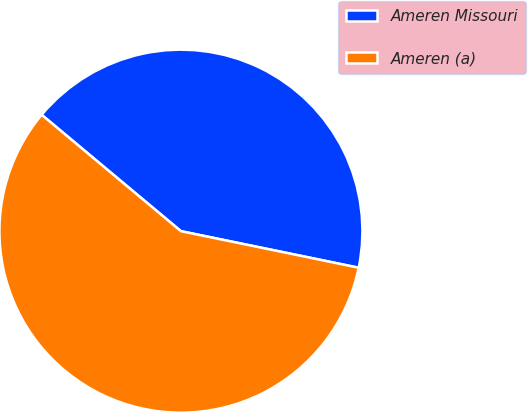Convert chart to OTSL. <chart><loc_0><loc_0><loc_500><loc_500><pie_chart><fcel>Ameren Missouri<fcel>Ameren (a)<nl><fcel>42.15%<fcel>57.85%<nl></chart> 